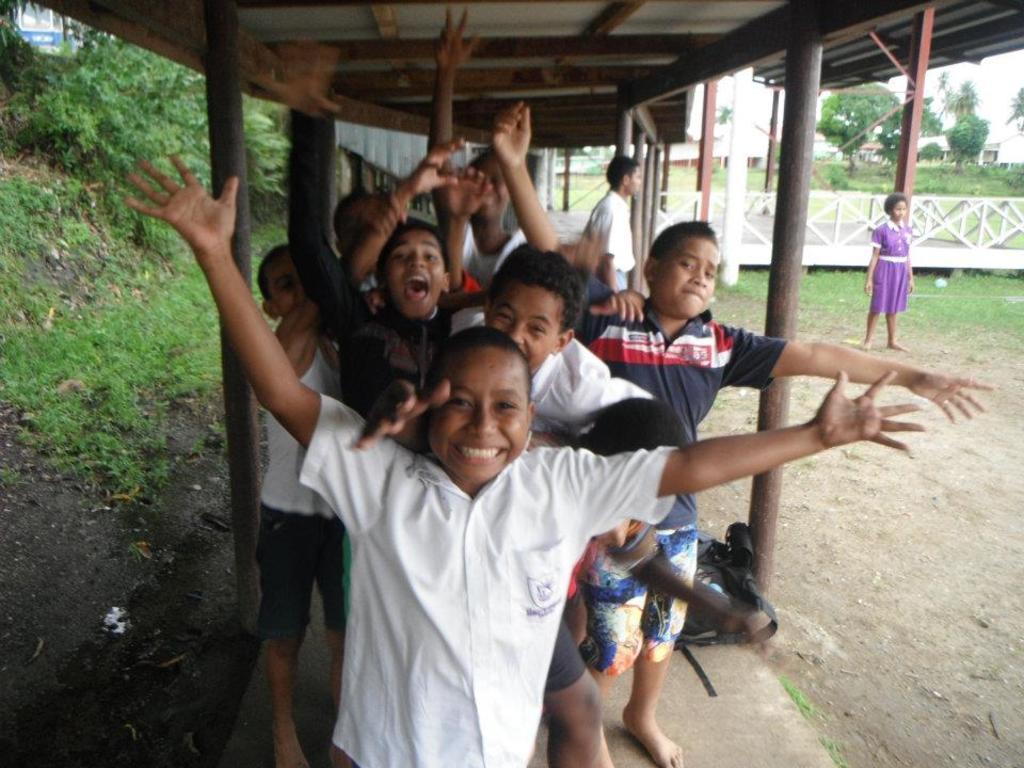In one or two sentences, can you explain what this image depicts? In this picture we can see a group of people standing on the ground,here we can see a shed,fence and trees. 